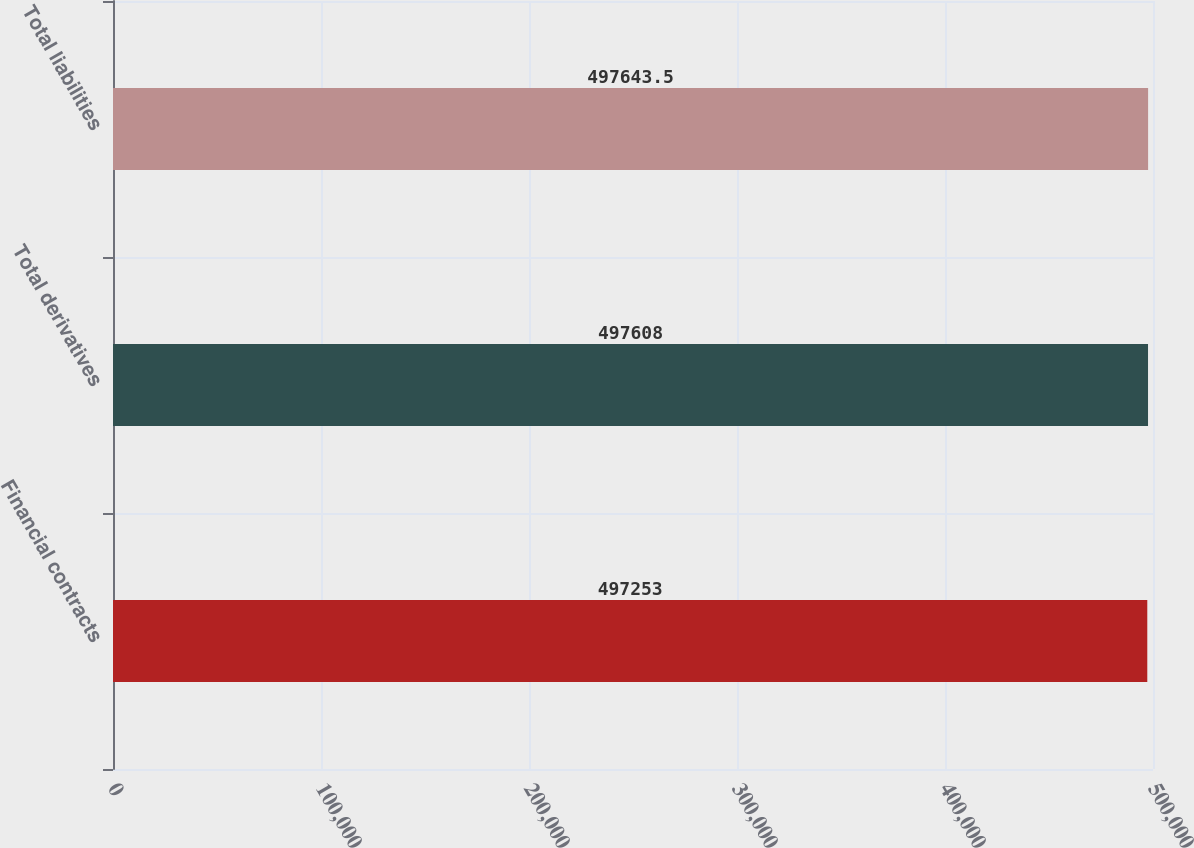Convert chart to OTSL. <chart><loc_0><loc_0><loc_500><loc_500><bar_chart><fcel>Financial contracts<fcel>Total derivatives<fcel>Total liabilities<nl><fcel>497253<fcel>497608<fcel>497644<nl></chart> 